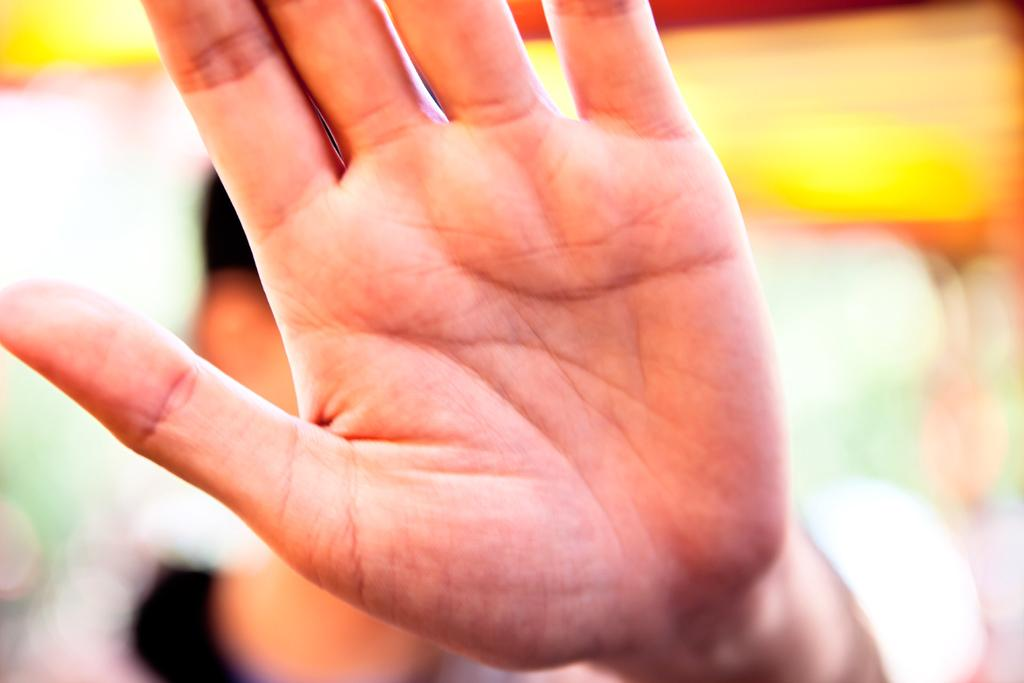What can be seen in the image that belongs to a person? There is a hand of a person in the image. Can you describe the background of the image? The background of the image is blurry. What type of rail can be seen in the image? There is no rail present in the image. How many roses are visible in the image? There are no roses visible in the image. 